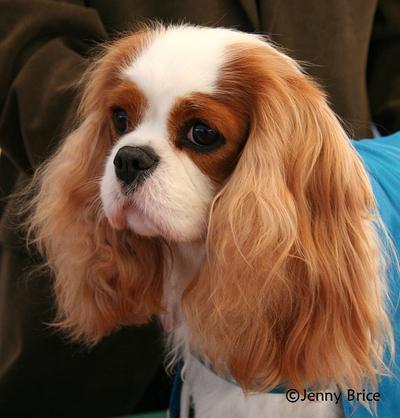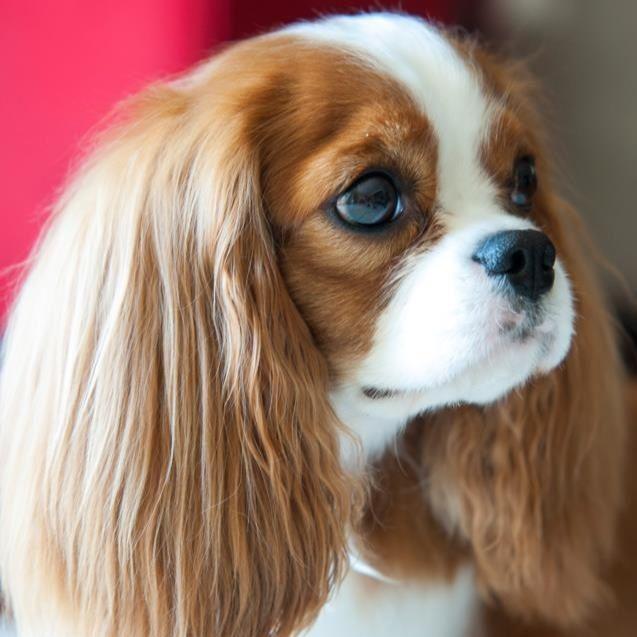The first image is the image on the left, the second image is the image on the right. Given the left and right images, does the statement "At least one King Charles puppy is shown next to their mother." hold true? Answer yes or no. No. The first image is the image on the left, the second image is the image on the right. Given the left and right images, does the statement "An image contains at least two dogs." hold true? Answer yes or no. No. 